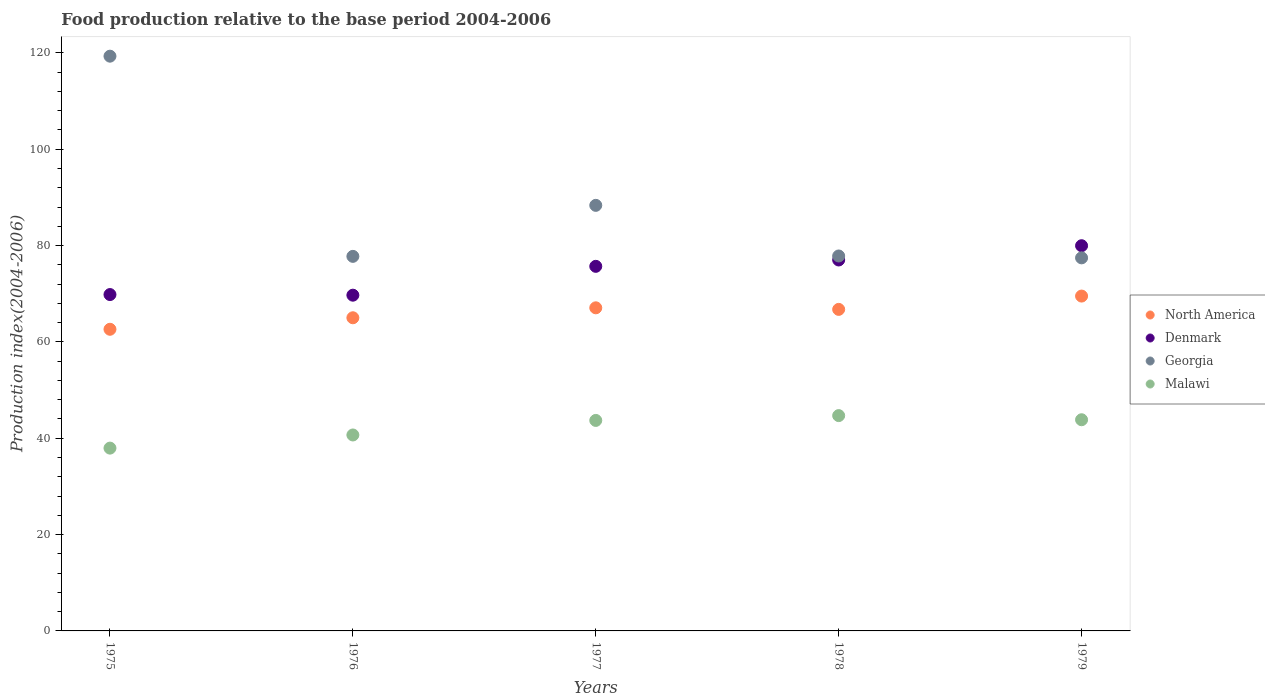Is the number of dotlines equal to the number of legend labels?
Keep it short and to the point. Yes. What is the food production index in North America in 1975?
Your answer should be compact. 62.62. Across all years, what is the maximum food production index in Georgia?
Ensure brevity in your answer.  119.32. Across all years, what is the minimum food production index in Malawi?
Your response must be concise. 37.95. In which year was the food production index in North America maximum?
Your answer should be compact. 1979. In which year was the food production index in Denmark minimum?
Give a very brief answer. 1976. What is the total food production index in Denmark in the graph?
Offer a very short reply. 372.2. What is the difference between the food production index in Denmark in 1976 and that in 1977?
Your answer should be compact. -5.99. What is the difference between the food production index in North America in 1979 and the food production index in Malawi in 1978?
Offer a very short reply. 24.82. What is the average food production index in Malawi per year?
Make the answer very short. 42.17. In the year 1976, what is the difference between the food production index in Georgia and food production index in Denmark?
Offer a terse response. 8.06. In how many years, is the food production index in North America greater than 108?
Give a very brief answer. 0. What is the ratio of the food production index in North America in 1975 to that in 1976?
Offer a terse response. 0.96. Is the food production index in Malawi in 1975 less than that in 1976?
Offer a terse response. Yes. What is the difference between the highest and the second highest food production index in North America?
Your response must be concise. 2.44. What is the difference between the highest and the lowest food production index in Georgia?
Ensure brevity in your answer.  41.87. Is the sum of the food production index in North America in 1976 and 1977 greater than the maximum food production index in Denmark across all years?
Your answer should be very brief. Yes. Is it the case that in every year, the sum of the food production index in North America and food production index in Georgia  is greater than the food production index in Denmark?
Offer a terse response. Yes. Does the food production index in Malawi monotonically increase over the years?
Offer a very short reply. No. Is the food production index in Malawi strictly less than the food production index in Georgia over the years?
Your answer should be compact. Yes. Does the graph contain any zero values?
Provide a short and direct response. No. Does the graph contain grids?
Keep it short and to the point. No. Where does the legend appear in the graph?
Offer a terse response. Center right. How many legend labels are there?
Ensure brevity in your answer.  4. How are the legend labels stacked?
Your response must be concise. Vertical. What is the title of the graph?
Your response must be concise. Food production relative to the base period 2004-2006. Does "Middle income" appear as one of the legend labels in the graph?
Offer a terse response. No. What is the label or title of the Y-axis?
Provide a succinct answer. Production index(2004-2006). What is the Production index(2004-2006) in North America in 1975?
Offer a very short reply. 62.62. What is the Production index(2004-2006) in Denmark in 1975?
Offer a very short reply. 69.83. What is the Production index(2004-2006) of Georgia in 1975?
Ensure brevity in your answer.  119.32. What is the Production index(2004-2006) of Malawi in 1975?
Your answer should be very brief. 37.95. What is the Production index(2004-2006) of North America in 1976?
Provide a short and direct response. 65.01. What is the Production index(2004-2006) in Denmark in 1976?
Offer a very short reply. 69.7. What is the Production index(2004-2006) of Georgia in 1976?
Provide a short and direct response. 77.76. What is the Production index(2004-2006) in Malawi in 1976?
Your answer should be compact. 40.68. What is the Production index(2004-2006) in North America in 1977?
Make the answer very short. 67.08. What is the Production index(2004-2006) in Denmark in 1977?
Your answer should be compact. 75.69. What is the Production index(2004-2006) in Georgia in 1977?
Provide a succinct answer. 88.35. What is the Production index(2004-2006) in Malawi in 1977?
Give a very brief answer. 43.7. What is the Production index(2004-2006) of North America in 1978?
Provide a succinct answer. 66.75. What is the Production index(2004-2006) of Denmark in 1978?
Provide a succinct answer. 77.01. What is the Production index(2004-2006) of Georgia in 1978?
Keep it short and to the point. 77.84. What is the Production index(2004-2006) in Malawi in 1978?
Make the answer very short. 44.7. What is the Production index(2004-2006) in North America in 1979?
Your answer should be very brief. 69.52. What is the Production index(2004-2006) in Denmark in 1979?
Offer a terse response. 79.97. What is the Production index(2004-2006) in Georgia in 1979?
Provide a succinct answer. 77.45. What is the Production index(2004-2006) in Malawi in 1979?
Offer a very short reply. 43.84. Across all years, what is the maximum Production index(2004-2006) in North America?
Provide a short and direct response. 69.52. Across all years, what is the maximum Production index(2004-2006) in Denmark?
Offer a terse response. 79.97. Across all years, what is the maximum Production index(2004-2006) of Georgia?
Provide a succinct answer. 119.32. Across all years, what is the maximum Production index(2004-2006) in Malawi?
Offer a very short reply. 44.7. Across all years, what is the minimum Production index(2004-2006) in North America?
Your answer should be very brief. 62.62. Across all years, what is the minimum Production index(2004-2006) in Denmark?
Ensure brevity in your answer.  69.7. Across all years, what is the minimum Production index(2004-2006) in Georgia?
Your response must be concise. 77.45. Across all years, what is the minimum Production index(2004-2006) in Malawi?
Offer a very short reply. 37.95. What is the total Production index(2004-2006) of North America in the graph?
Provide a succinct answer. 330.98. What is the total Production index(2004-2006) of Denmark in the graph?
Give a very brief answer. 372.2. What is the total Production index(2004-2006) of Georgia in the graph?
Your response must be concise. 440.72. What is the total Production index(2004-2006) of Malawi in the graph?
Give a very brief answer. 210.87. What is the difference between the Production index(2004-2006) of North America in 1975 and that in 1976?
Keep it short and to the point. -2.39. What is the difference between the Production index(2004-2006) in Denmark in 1975 and that in 1976?
Make the answer very short. 0.13. What is the difference between the Production index(2004-2006) in Georgia in 1975 and that in 1976?
Offer a terse response. 41.56. What is the difference between the Production index(2004-2006) of Malawi in 1975 and that in 1976?
Your answer should be compact. -2.73. What is the difference between the Production index(2004-2006) in North America in 1975 and that in 1977?
Give a very brief answer. -4.46. What is the difference between the Production index(2004-2006) of Denmark in 1975 and that in 1977?
Offer a very short reply. -5.86. What is the difference between the Production index(2004-2006) of Georgia in 1975 and that in 1977?
Provide a short and direct response. 30.97. What is the difference between the Production index(2004-2006) in Malawi in 1975 and that in 1977?
Offer a terse response. -5.75. What is the difference between the Production index(2004-2006) of North America in 1975 and that in 1978?
Give a very brief answer. -4.13. What is the difference between the Production index(2004-2006) in Denmark in 1975 and that in 1978?
Give a very brief answer. -7.18. What is the difference between the Production index(2004-2006) in Georgia in 1975 and that in 1978?
Your response must be concise. 41.48. What is the difference between the Production index(2004-2006) of Malawi in 1975 and that in 1978?
Provide a short and direct response. -6.75. What is the difference between the Production index(2004-2006) of North America in 1975 and that in 1979?
Offer a very short reply. -6.89. What is the difference between the Production index(2004-2006) of Denmark in 1975 and that in 1979?
Offer a terse response. -10.14. What is the difference between the Production index(2004-2006) of Georgia in 1975 and that in 1979?
Offer a terse response. 41.87. What is the difference between the Production index(2004-2006) in Malawi in 1975 and that in 1979?
Your answer should be compact. -5.89. What is the difference between the Production index(2004-2006) in North America in 1976 and that in 1977?
Ensure brevity in your answer.  -2.06. What is the difference between the Production index(2004-2006) of Denmark in 1976 and that in 1977?
Make the answer very short. -5.99. What is the difference between the Production index(2004-2006) in Georgia in 1976 and that in 1977?
Offer a terse response. -10.59. What is the difference between the Production index(2004-2006) in Malawi in 1976 and that in 1977?
Provide a succinct answer. -3.02. What is the difference between the Production index(2004-2006) in North America in 1976 and that in 1978?
Your response must be concise. -1.74. What is the difference between the Production index(2004-2006) of Denmark in 1976 and that in 1978?
Provide a succinct answer. -7.31. What is the difference between the Production index(2004-2006) of Georgia in 1976 and that in 1978?
Offer a terse response. -0.08. What is the difference between the Production index(2004-2006) of Malawi in 1976 and that in 1978?
Give a very brief answer. -4.02. What is the difference between the Production index(2004-2006) in North America in 1976 and that in 1979?
Your answer should be very brief. -4.5. What is the difference between the Production index(2004-2006) of Denmark in 1976 and that in 1979?
Your answer should be compact. -10.27. What is the difference between the Production index(2004-2006) of Georgia in 1976 and that in 1979?
Provide a succinct answer. 0.31. What is the difference between the Production index(2004-2006) of Malawi in 1976 and that in 1979?
Your answer should be compact. -3.16. What is the difference between the Production index(2004-2006) of North America in 1977 and that in 1978?
Keep it short and to the point. 0.32. What is the difference between the Production index(2004-2006) of Denmark in 1977 and that in 1978?
Offer a terse response. -1.32. What is the difference between the Production index(2004-2006) in Georgia in 1977 and that in 1978?
Offer a very short reply. 10.51. What is the difference between the Production index(2004-2006) of Malawi in 1977 and that in 1978?
Provide a succinct answer. -1. What is the difference between the Production index(2004-2006) in North America in 1977 and that in 1979?
Keep it short and to the point. -2.44. What is the difference between the Production index(2004-2006) in Denmark in 1977 and that in 1979?
Make the answer very short. -4.28. What is the difference between the Production index(2004-2006) of Georgia in 1977 and that in 1979?
Your answer should be compact. 10.9. What is the difference between the Production index(2004-2006) of Malawi in 1977 and that in 1979?
Make the answer very short. -0.14. What is the difference between the Production index(2004-2006) of North America in 1978 and that in 1979?
Make the answer very short. -2.76. What is the difference between the Production index(2004-2006) in Denmark in 1978 and that in 1979?
Your answer should be compact. -2.96. What is the difference between the Production index(2004-2006) of Georgia in 1978 and that in 1979?
Make the answer very short. 0.39. What is the difference between the Production index(2004-2006) of Malawi in 1978 and that in 1979?
Your answer should be very brief. 0.86. What is the difference between the Production index(2004-2006) of North America in 1975 and the Production index(2004-2006) of Denmark in 1976?
Make the answer very short. -7.08. What is the difference between the Production index(2004-2006) in North America in 1975 and the Production index(2004-2006) in Georgia in 1976?
Your answer should be compact. -15.14. What is the difference between the Production index(2004-2006) in North America in 1975 and the Production index(2004-2006) in Malawi in 1976?
Offer a very short reply. 21.94. What is the difference between the Production index(2004-2006) of Denmark in 1975 and the Production index(2004-2006) of Georgia in 1976?
Give a very brief answer. -7.93. What is the difference between the Production index(2004-2006) of Denmark in 1975 and the Production index(2004-2006) of Malawi in 1976?
Your response must be concise. 29.15. What is the difference between the Production index(2004-2006) in Georgia in 1975 and the Production index(2004-2006) in Malawi in 1976?
Provide a succinct answer. 78.64. What is the difference between the Production index(2004-2006) of North America in 1975 and the Production index(2004-2006) of Denmark in 1977?
Provide a succinct answer. -13.07. What is the difference between the Production index(2004-2006) of North America in 1975 and the Production index(2004-2006) of Georgia in 1977?
Provide a succinct answer. -25.73. What is the difference between the Production index(2004-2006) in North America in 1975 and the Production index(2004-2006) in Malawi in 1977?
Give a very brief answer. 18.92. What is the difference between the Production index(2004-2006) in Denmark in 1975 and the Production index(2004-2006) in Georgia in 1977?
Offer a terse response. -18.52. What is the difference between the Production index(2004-2006) of Denmark in 1975 and the Production index(2004-2006) of Malawi in 1977?
Offer a terse response. 26.13. What is the difference between the Production index(2004-2006) in Georgia in 1975 and the Production index(2004-2006) in Malawi in 1977?
Offer a terse response. 75.62. What is the difference between the Production index(2004-2006) of North America in 1975 and the Production index(2004-2006) of Denmark in 1978?
Your answer should be compact. -14.39. What is the difference between the Production index(2004-2006) of North America in 1975 and the Production index(2004-2006) of Georgia in 1978?
Your answer should be very brief. -15.22. What is the difference between the Production index(2004-2006) in North America in 1975 and the Production index(2004-2006) in Malawi in 1978?
Offer a very short reply. 17.92. What is the difference between the Production index(2004-2006) of Denmark in 1975 and the Production index(2004-2006) of Georgia in 1978?
Offer a terse response. -8.01. What is the difference between the Production index(2004-2006) in Denmark in 1975 and the Production index(2004-2006) in Malawi in 1978?
Your answer should be compact. 25.13. What is the difference between the Production index(2004-2006) in Georgia in 1975 and the Production index(2004-2006) in Malawi in 1978?
Ensure brevity in your answer.  74.62. What is the difference between the Production index(2004-2006) in North America in 1975 and the Production index(2004-2006) in Denmark in 1979?
Provide a succinct answer. -17.35. What is the difference between the Production index(2004-2006) in North America in 1975 and the Production index(2004-2006) in Georgia in 1979?
Keep it short and to the point. -14.83. What is the difference between the Production index(2004-2006) in North America in 1975 and the Production index(2004-2006) in Malawi in 1979?
Your answer should be very brief. 18.78. What is the difference between the Production index(2004-2006) of Denmark in 1975 and the Production index(2004-2006) of Georgia in 1979?
Keep it short and to the point. -7.62. What is the difference between the Production index(2004-2006) in Denmark in 1975 and the Production index(2004-2006) in Malawi in 1979?
Provide a succinct answer. 25.99. What is the difference between the Production index(2004-2006) of Georgia in 1975 and the Production index(2004-2006) of Malawi in 1979?
Offer a very short reply. 75.48. What is the difference between the Production index(2004-2006) in North America in 1976 and the Production index(2004-2006) in Denmark in 1977?
Your answer should be compact. -10.68. What is the difference between the Production index(2004-2006) of North America in 1976 and the Production index(2004-2006) of Georgia in 1977?
Offer a very short reply. -23.34. What is the difference between the Production index(2004-2006) of North America in 1976 and the Production index(2004-2006) of Malawi in 1977?
Make the answer very short. 21.31. What is the difference between the Production index(2004-2006) of Denmark in 1976 and the Production index(2004-2006) of Georgia in 1977?
Ensure brevity in your answer.  -18.65. What is the difference between the Production index(2004-2006) in Georgia in 1976 and the Production index(2004-2006) in Malawi in 1977?
Offer a very short reply. 34.06. What is the difference between the Production index(2004-2006) of North America in 1976 and the Production index(2004-2006) of Denmark in 1978?
Offer a very short reply. -12. What is the difference between the Production index(2004-2006) in North America in 1976 and the Production index(2004-2006) in Georgia in 1978?
Your answer should be very brief. -12.83. What is the difference between the Production index(2004-2006) in North America in 1976 and the Production index(2004-2006) in Malawi in 1978?
Your response must be concise. 20.31. What is the difference between the Production index(2004-2006) in Denmark in 1976 and the Production index(2004-2006) in Georgia in 1978?
Your response must be concise. -8.14. What is the difference between the Production index(2004-2006) of Denmark in 1976 and the Production index(2004-2006) of Malawi in 1978?
Offer a very short reply. 25. What is the difference between the Production index(2004-2006) of Georgia in 1976 and the Production index(2004-2006) of Malawi in 1978?
Make the answer very short. 33.06. What is the difference between the Production index(2004-2006) in North America in 1976 and the Production index(2004-2006) in Denmark in 1979?
Give a very brief answer. -14.96. What is the difference between the Production index(2004-2006) of North America in 1976 and the Production index(2004-2006) of Georgia in 1979?
Your answer should be very brief. -12.44. What is the difference between the Production index(2004-2006) in North America in 1976 and the Production index(2004-2006) in Malawi in 1979?
Ensure brevity in your answer.  21.17. What is the difference between the Production index(2004-2006) of Denmark in 1976 and the Production index(2004-2006) of Georgia in 1979?
Your answer should be compact. -7.75. What is the difference between the Production index(2004-2006) of Denmark in 1976 and the Production index(2004-2006) of Malawi in 1979?
Keep it short and to the point. 25.86. What is the difference between the Production index(2004-2006) of Georgia in 1976 and the Production index(2004-2006) of Malawi in 1979?
Offer a terse response. 33.92. What is the difference between the Production index(2004-2006) of North America in 1977 and the Production index(2004-2006) of Denmark in 1978?
Make the answer very short. -9.93. What is the difference between the Production index(2004-2006) in North America in 1977 and the Production index(2004-2006) in Georgia in 1978?
Your answer should be compact. -10.76. What is the difference between the Production index(2004-2006) in North America in 1977 and the Production index(2004-2006) in Malawi in 1978?
Offer a terse response. 22.38. What is the difference between the Production index(2004-2006) of Denmark in 1977 and the Production index(2004-2006) of Georgia in 1978?
Your answer should be very brief. -2.15. What is the difference between the Production index(2004-2006) in Denmark in 1977 and the Production index(2004-2006) in Malawi in 1978?
Your response must be concise. 30.99. What is the difference between the Production index(2004-2006) in Georgia in 1977 and the Production index(2004-2006) in Malawi in 1978?
Keep it short and to the point. 43.65. What is the difference between the Production index(2004-2006) of North America in 1977 and the Production index(2004-2006) of Denmark in 1979?
Your response must be concise. -12.89. What is the difference between the Production index(2004-2006) in North America in 1977 and the Production index(2004-2006) in Georgia in 1979?
Your response must be concise. -10.37. What is the difference between the Production index(2004-2006) of North America in 1977 and the Production index(2004-2006) of Malawi in 1979?
Ensure brevity in your answer.  23.24. What is the difference between the Production index(2004-2006) of Denmark in 1977 and the Production index(2004-2006) of Georgia in 1979?
Give a very brief answer. -1.76. What is the difference between the Production index(2004-2006) of Denmark in 1977 and the Production index(2004-2006) of Malawi in 1979?
Give a very brief answer. 31.85. What is the difference between the Production index(2004-2006) of Georgia in 1977 and the Production index(2004-2006) of Malawi in 1979?
Provide a succinct answer. 44.51. What is the difference between the Production index(2004-2006) of North America in 1978 and the Production index(2004-2006) of Denmark in 1979?
Ensure brevity in your answer.  -13.22. What is the difference between the Production index(2004-2006) in North America in 1978 and the Production index(2004-2006) in Georgia in 1979?
Provide a succinct answer. -10.7. What is the difference between the Production index(2004-2006) in North America in 1978 and the Production index(2004-2006) in Malawi in 1979?
Provide a succinct answer. 22.91. What is the difference between the Production index(2004-2006) of Denmark in 1978 and the Production index(2004-2006) of Georgia in 1979?
Provide a succinct answer. -0.44. What is the difference between the Production index(2004-2006) in Denmark in 1978 and the Production index(2004-2006) in Malawi in 1979?
Provide a succinct answer. 33.17. What is the average Production index(2004-2006) in North America per year?
Your answer should be compact. 66.2. What is the average Production index(2004-2006) in Denmark per year?
Make the answer very short. 74.44. What is the average Production index(2004-2006) of Georgia per year?
Give a very brief answer. 88.14. What is the average Production index(2004-2006) of Malawi per year?
Offer a terse response. 42.17. In the year 1975, what is the difference between the Production index(2004-2006) of North America and Production index(2004-2006) of Denmark?
Ensure brevity in your answer.  -7.21. In the year 1975, what is the difference between the Production index(2004-2006) of North America and Production index(2004-2006) of Georgia?
Keep it short and to the point. -56.7. In the year 1975, what is the difference between the Production index(2004-2006) of North America and Production index(2004-2006) of Malawi?
Provide a short and direct response. 24.67. In the year 1975, what is the difference between the Production index(2004-2006) in Denmark and Production index(2004-2006) in Georgia?
Provide a short and direct response. -49.49. In the year 1975, what is the difference between the Production index(2004-2006) in Denmark and Production index(2004-2006) in Malawi?
Give a very brief answer. 31.88. In the year 1975, what is the difference between the Production index(2004-2006) in Georgia and Production index(2004-2006) in Malawi?
Keep it short and to the point. 81.37. In the year 1976, what is the difference between the Production index(2004-2006) of North America and Production index(2004-2006) of Denmark?
Provide a short and direct response. -4.69. In the year 1976, what is the difference between the Production index(2004-2006) of North America and Production index(2004-2006) of Georgia?
Your response must be concise. -12.75. In the year 1976, what is the difference between the Production index(2004-2006) in North America and Production index(2004-2006) in Malawi?
Your response must be concise. 24.33. In the year 1976, what is the difference between the Production index(2004-2006) of Denmark and Production index(2004-2006) of Georgia?
Your answer should be compact. -8.06. In the year 1976, what is the difference between the Production index(2004-2006) of Denmark and Production index(2004-2006) of Malawi?
Provide a short and direct response. 29.02. In the year 1976, what is the difference between the Production index(2004-2006) in Georgia and Production index(2004-2006) in Malawi?
Give a very brief answer. 37.08. In the year 1977, what is the difference between the Production index(2004-2006) in North America and Production index(2004-2006) in Denmark?
Keep it short and to the point. -8.61. In the year 1977, what is the difference between the Production index(2004-2006) of North America and Production index(2004-2006) of Georgia?
Your response must be concise. -21.27. In the year 1977, what is the difference between the Production index(2004-2006) in North America and Production index(2004-2006) in Malawi?
Ensure brevity in your answer.  23.38. In the year 1977, what is the difference between the Production index(2004-2006) in Denmark and Production index(2004-2006) in Georgia?
Offer a terse response. -12.66. In the year 1977, what is the difference between the Production index(2004-2006) of Denmark and Production index(2004-2006) of Malawi?
Offer a very short reply. 31.99. In the year 1977, what is the difference between the Production index(2004-2006) in Georgia and Production index(2004-2006) in Malawi?
Your answer should be compact. 44.65. In the year 1978, what is the difference between the Production index(2004-2006) in North America and Production index(2004-2006) in Denmark?
Provide a short and direct response. -10.26. In the year 1978, what is the difference between the Production index(2004-2006) in North America and Production index(2004-2006) in Georgia?
Your answer should be very brief. -11.09. In the year 1978, what is the difference between the Production index(2004-2006) in North America and Production index(2004-2006) in Malawi?
Give a very brief answer. 22.05. In the year 1978, what is the difference between the Production index(2004-2006) in Denmark and Production index(2004-2006) in Georgia?
Provide a short and direct response. -0.83. In the year 1978, what is the difference between the Production index(2004-2006) of Denmark and Production index(2004-2006) of Malawi?
Make the answer very short. 32.31. In the year 1978, what is the difference between the Production index(2004-2006) in Georgia and Production index(2004-2006) in Malawi?
Offer a very short reply. 33.14. In the year 1979, what is the difference between the Production index(2004-2006) of North America and Production index(2004-2006) of Denmark?
Offer a terse response. -10.45. In the year 1979, what is the difference between the Production index(2004-2006) of North America and Production index(2004-2006) of Georgia?
Ensure brevity in your answer.  -7.93. In the year 1979, what is the difference between the Production index(2004-2006) in North America and Production index(2004-2006) in Malawi?
Your response must be concise. 25.68. In the year 1979, what is the difference between the Production index(2004-2006) in Denmark and Production index(2004-2006) in Georgia?
Ensure brevity in your answer.  2.52. In the year 1979, what is the difference between the Production index(2004-2006) in Denmark and Production index(2004-2006) in Malawi?
Provide a succinct answer. 36.13. In the year 1979, what is the difference between the Production index(2004-2006) of Georgia and Production index(2004-2006) of Malawi?
Ensure brevity in your answer.  33.61. What is the ratio of the Production index(2004-2006) of North America in 1975 to that in 1976?
Keep it short and to the point. 0.96. What is the ratio of the Production index(2004-2006) in Georgia in 1975 to that in 1976?
Offer a very short reply. 1.53. What is the ratio of the Production index(2004-2006) in Malawi in 1975 to that in 1976?
Keep it short and to the point. 0.93. What is the ratio of the Production index(2004-2006) of North America in 1975 to that in 1977?
Offer a very short reply. 0.93. What is the ratio of the Production index(2004-2006) of Denmark in 1975 to that in 1977?
Provide a short and direct response. 0.92. What is the ratio of the Production index(2004-2006) in Georgia in 1975 to that in 1977?
Your answer should be compact. 1.35. What is the ratio of the Production index(2004-2006) in Malawi in 1975 to that in 1977?
Your answer should be very brief. 0.87. What is the ratio of the Production index(2004-2006) in North America in 1975 to that in 1978?
Keep it short and to the point. 0.94. What is the ratio of the Production index(2004-2006) of Denmark in 1975 to that in 1978?
Provide a succinct answer. 0.91. What is the ratio of the Production index(2004-2006) in Georgia in 1975 to that in 1978?
Give a very brief answer. 1.53. What is the ratio of the Production index(2004-2006) in Malawi in 1975 to that in 1978?
Your answer should be compact. 0.85. What is the ratio of the Production index(2004-2006) of North America in 1975 to that in 1979?
Keep it short and to the point. 0.9. What is the ratio of the Production index(2004-2006) of Denmark in 1975 to that in 1979?
Provide a succinct answer. 0.87. What is the ratio of the Production index(2004-2006) of Georgia in 1975 to that in 1979?
Offer a very short reply. 1.54. What is the ratio of the Production index(2004-2006) of Malawi in 1975 to that in 1979?
Your answer should be very brief. 0.87. What is the ratio of the Production index(2004-2006) of North America in 1976 to that in 1977?
Give a very brief answer. 0.97. What is the ratio of the Production index(2004-2006) of Denmark in 1976 to that in 1977?
Provide a short and direct response. 0.92. What is the ratio of the Production index(2004-2006) in Georgia in 1976 to that in 1977?
Your answer should be very brief. 0.88. What is the ratio of the Production index(2004-2006) of Malawi in 1976 to that in 1977?
Offer a terse response. 0.93. What is the ratio of the Production index(2004-2006) in North America in 1976 to that in 1978?
Keep it short and to the point. 0.97. What is the ratio of the Production index(2004-2006) of Denmark in 1976 to that in 1978?
Offer a terse response. 0.91. What is the ratio of the Production index(2004-2006) of Malawi in 1976 to that in 1978?
Make the answer very short. 0.91. What is the ratio of the Production index(2004-2006) in North America in 1976 to that in 1979?
Offer a terse response. 0.94. What is the ratio of the Production index(2004-2006) in Denmark in 1976 to that in 1979?
Your answer should be compact. 0.87. What is the ratio of the Production index(2004-2006) of Malawi in 1976 to that in 1979?
Offer a terse response. 0.93. What is the ratio of the Production index(2004-2006) of Denmark in 1977 to that in 1978?
Ensure brevity in your answer.  0.98. What is the ratio of the Production index(2004-2006) of Georgia in 1977 to that in 1978?
Give a very brief answer. 1.14. What is the ratio of the Production index(2004-2006) in Malawi in 1977 to that in 1978?
Your answer should be compact. 0.98. What is the ratio of the Production index(2004-2006) in North America in 1977 to that in 1979?
Offer a very short reply. 0.96. What is the ratio of the Production index(2004-2006) of Denmark in 1977 to that in 1979?
Ensure brevity in your answer.  0.95. What is the ratio of the Production index(2004-2006) of Georgia in 1977 to that in 1979?
Provide a short and direct response. 1.14. What is the ratio of the Production index(2004-2006) in North America in 1978 to that in 1979?
Provide a short and direct response. 0.96. What is the ratio of the Production index(2004-2006) in Georgia in 1978 to that in 1979?
Offer a very short reply. 1. What is the ratio of the Production index(2004-2006) in Malawi in 1978 to that in 1979?
Make the answer very short. 1.02. What is the difference between the highest and the second highest Production index(2004-2006) of North America?
Make the answer very short. 2.44. What is the difference between the highest and the second highest Production index(2004-2006) in Denmark?
Give a very brief answer. 2.96. What is the difference between the highest and the second highest Production index(2004-2006) of Georgia?
Offer a terse response. 30.97. What is the difference between the highest and the second highest Production index(2004-2006) of Malawi?
Offer a terse response. 0.86. What is the difference between the highest and the lowest Production index(2004-2006) in North America?
Make the answer very short. 6.89. What is the difference between the highest and the lowest Production index(2004-2006) in Denmark?
Your answer should be very brief. 10.27. What is the difference between the highest and the lowest Production index(2004-2006) of Georgia?
Ensure brevity in your answer.  41.87. What is the difference between the highest and the lowest Production index(2004-2006) in Malawi?
Offer a terse response. 6.75. 